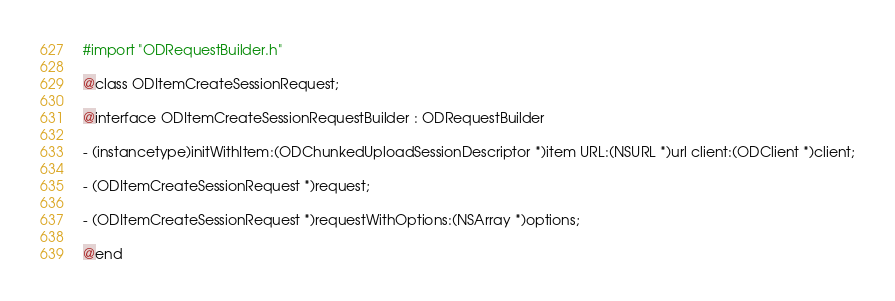<code> <loc_0><loc_0><loc_500><loc_500><_C_>#import "ODRequestBuilder.h"

@class ODItemCreateSessionRequest;

@interface ODItemCreateSessionRequestBuilder : ODRequestBuilder

- (instancetype)initWithItem:(ODChunkedUploadSessionDescriptor *)item URL:(NSURL *)url client:(ODClient *)client;

- (ODItemCreateSessionRequest *)request;

- (ODItemCreateSessionRequest *)requestWithOptions:(NSArray *)options;

@end
</code> 